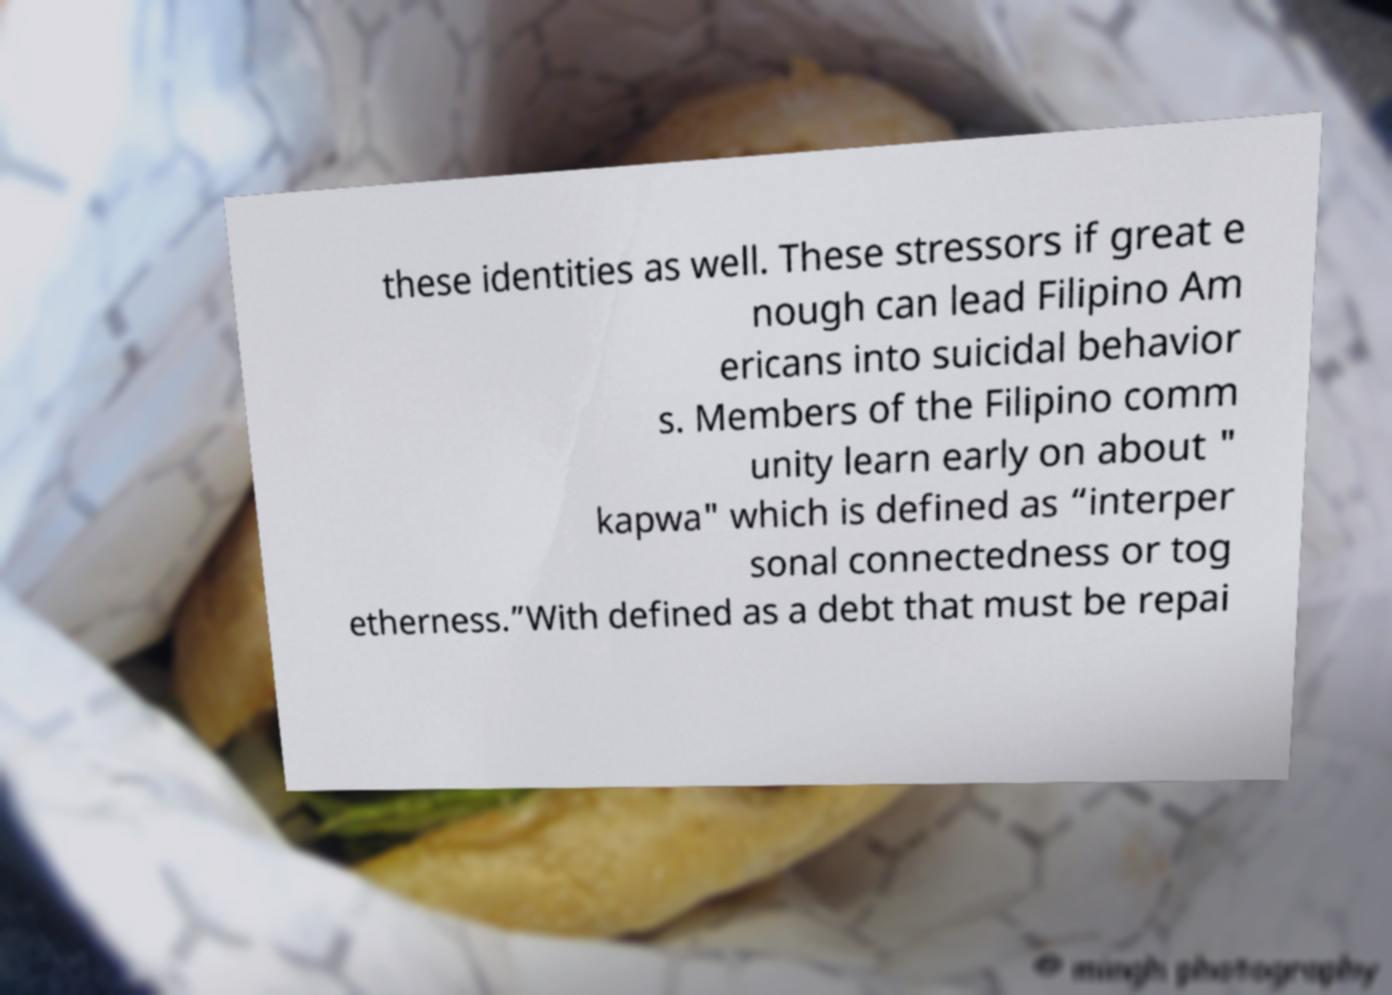Could you extract and type out the text from this image? these identities as well. These stressors if great e nough can lead Filipino Am ericans into suicidal behavior s. Members of the Filipino comm unity learn early on about " kapwa" which is defined as “interper sonal connectedness or tog etherness.”With defined as a debt that must be repai 